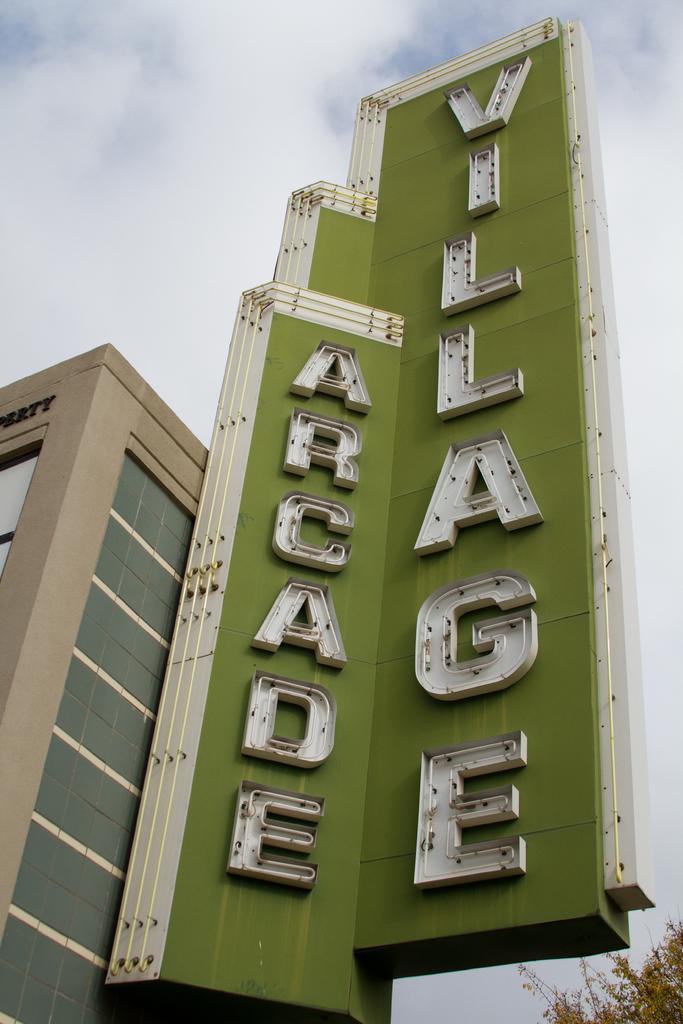Can you describe this image briefly? In the picture there is a building and beside the building there is a name written on a green background, it is very huge and in the background there is a sky. 